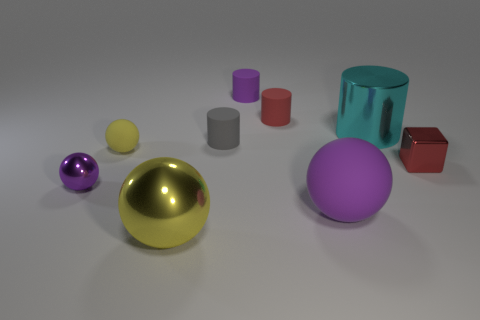Are any tiny purple matte objects visible?
Provide a short and direct response. Yes. Is the shape of the small yellow thing the same as the yellow shiny thing?
Your response must be concise. Yes. What number of large objects are either shiny blocks or blue metallic cylinders?
Your answer should be very brief. 0. What color is the large matte sphere?
Your response must be concise. Purple. What is the shape of the small shiny thing that is behind the tiny purple object left of the gray thing?
Keep it short and to the point. Cube. Are there any small yellow spheres that have the same material as the tiny yellow object?
Make the answer very short. No. Does the red thing right of the cyan cylinder have the same size as the purple metal ball?
Give a very brief answer. Yes. How many cyan things are rubber cylinders or balls?
Give a very brief answer. 0. What is the material of the red thing that is left of the small red block?
Keep it short and to the point. Rubber. How many small spheres are in front of the tiny metal thing that is right of the gray cylinder?
Offer a terse response. 1. 